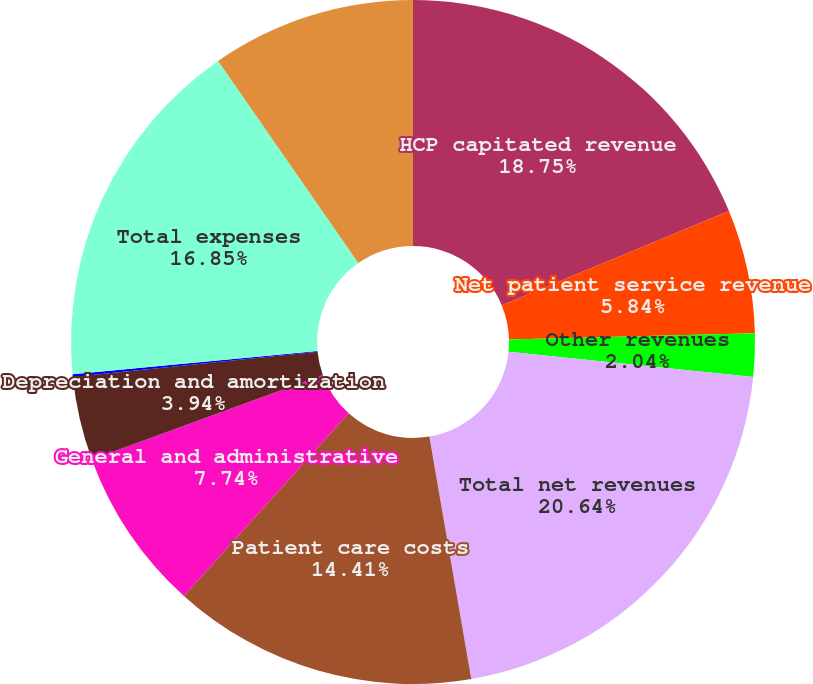Convert chart to OTSL. <chart><loc_0><loc_0><loc_500><loc_500><pie_chart><fcel>HCP capitated revenue<fcel>Net patient service revenue<fcel>Other revenues<fcel>Total net revenues<fcel>Patient care costs<fcel>General and administrative<fcel>Depreciation and amortization<fcel>Equity investment income<fcel>Total expenses<fcel>Operating income<nl><fcel>18.75%<fcel>5.84%<fcel>2.04%<fcel>20.65%<fcel>14.41%<fcel>7.74%<fcel>3.94%<fcel>0.14%<fcel>16.85%<fcel>9.65%<nl></chart> 